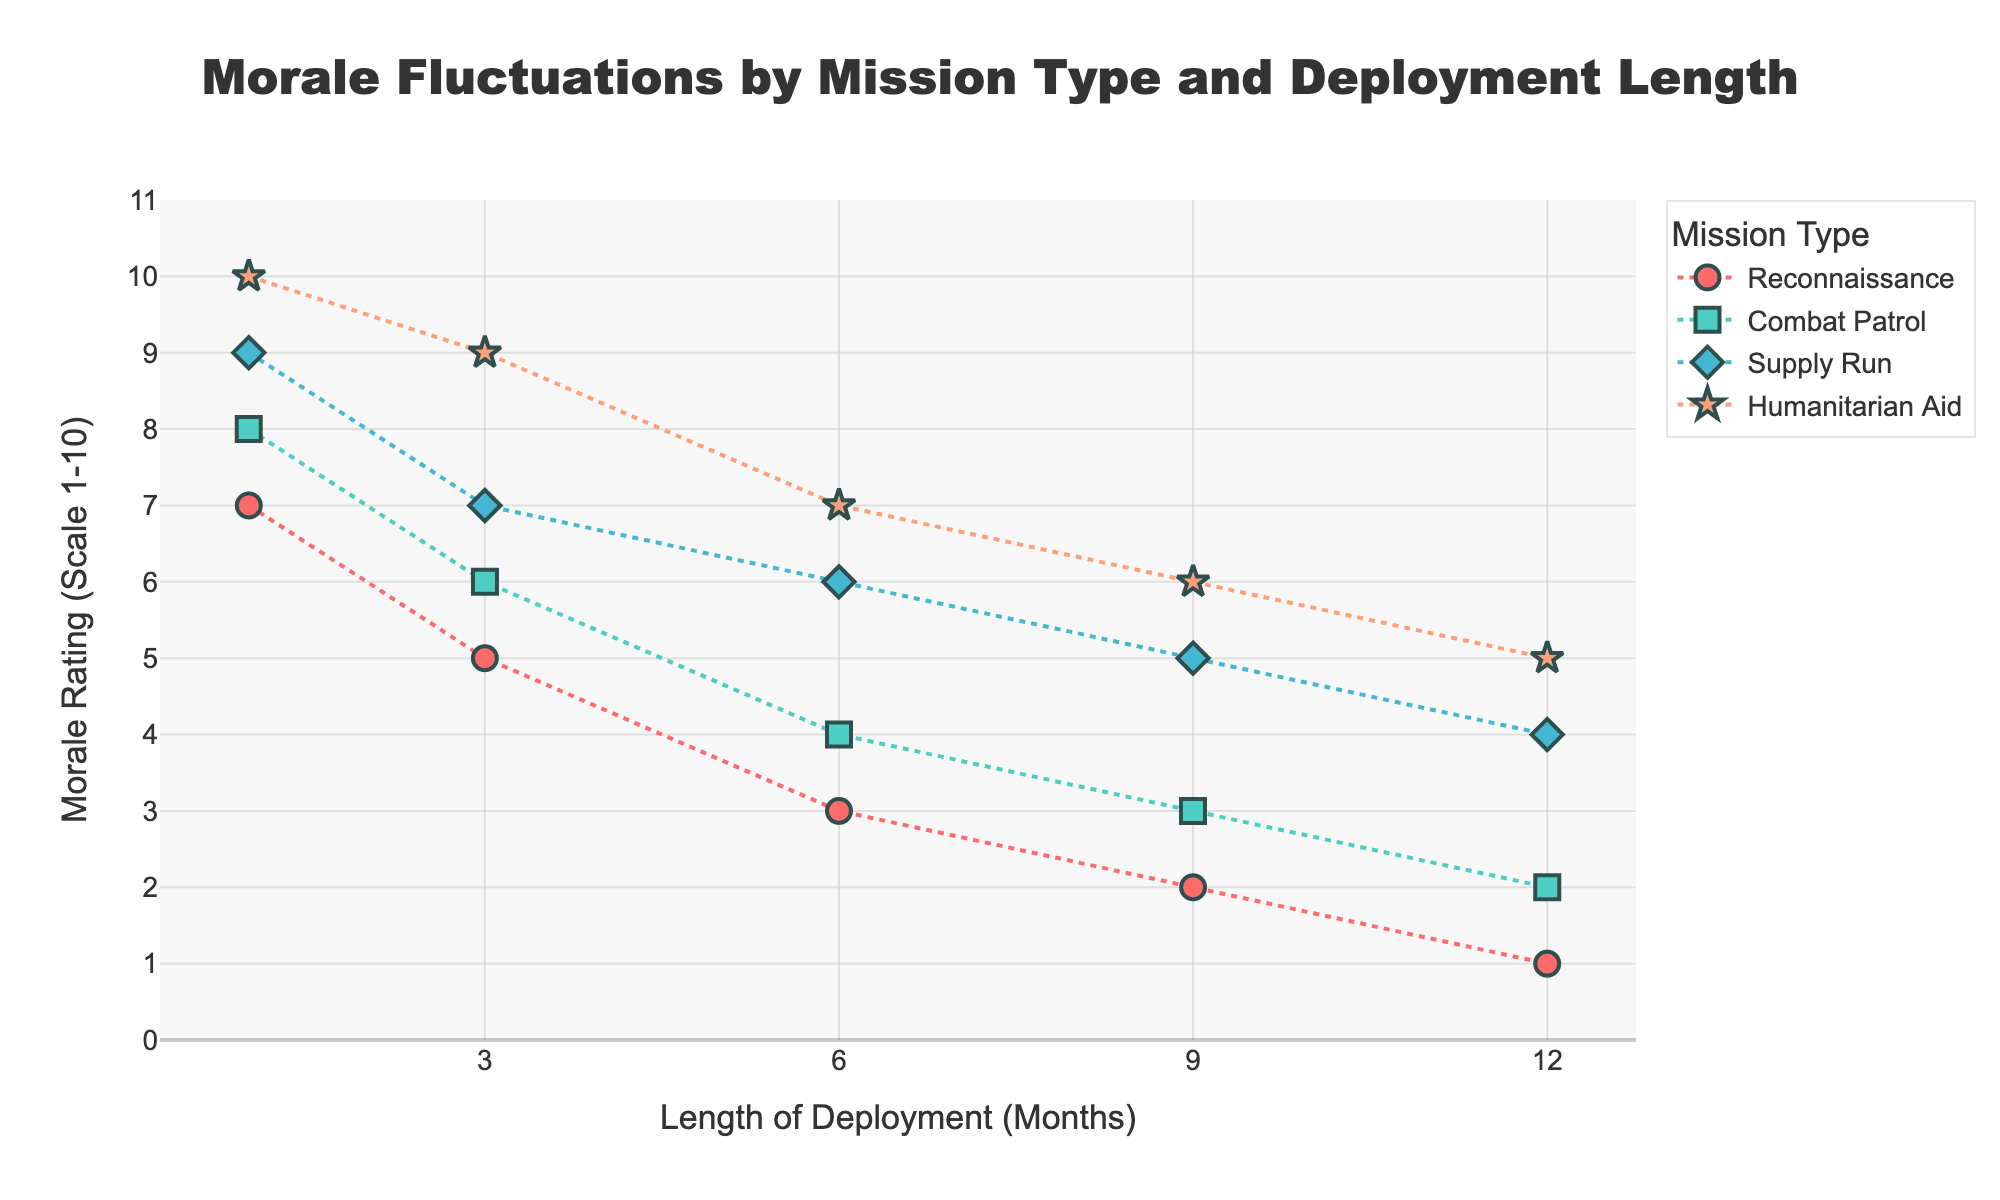What is the title of the plot? The title of the plot is prominently displayed at the top. Simply reading it provides the answer.
Answer: Morale Fluctuations by Mission Type and Deployment Length What is the morale rating for a reconnaissance mission at 6 months? Locate the 'Reconnaissance' mission line on the plot and find the data point where the length of deployment is 6 months. The y-axis value of this point is the morale rating.
Answer: 3 Which mission type has the highest initial morale rating? Look at the data points corresponding to the 1-month deployment mark for all mission types. Compare the morale ratings to identify the highest one.
Answer: Humanitarian Aid By how much does the morale rating decrease for Combat Patrol between months 1 and 12? Check the morale ratings for Combat Patrol at 1 month (8) and 12 months (2). Subtract the morale rating at 12 months from that at 1 month: 8 - 2.
Answer: 6 Which mission type shows the least fluctuation in morale over the deployment period? Compare the range of morale ratings for each mission type. The mission with the smallest range (difference between maximum and minimum morale ratings) exhibits the least fluctuation.
Answer: Humanitarian Aid How does the morale rating for Supply Run change from 3 months to 9 months? Note the morale ratings for Supply Run at 3 months (7) and 9 months (5). Calculate the difference: 7 - 5.
Answer: Decreases by 2 At 9 months deployment, which mission type has the lowest morale rating and what is the value? Look at the y-axis values for all mission types at the 9 months mark. Identify the mission type with the lowest y-axis value and note the value.
Answer: Reconnaissance, 2 If you average the morale ratings for Reconnaissance at 1 and 12 months, what value do you get? Find the morale ratings for Reconnaissance at 1 month (7) and 12 months (1). Calculate the average: (7 + 1) / 2.
Answer: 4 Which mission type has morale ratings that consistently decrease as deployment length increases? Observe the trend lines for all mission types. The line that shows a continuous decrease in y-axis values across increasing deployment lengths is the answer.
Answer: All mission types Between months 3 and 6, which mission type shows the greatest drop in morale rating? Compare the differences in morale ratings from 3 to 6 months for all mission types. Identify the mission type with the largest decrease.
Answer: Reconnaissance 